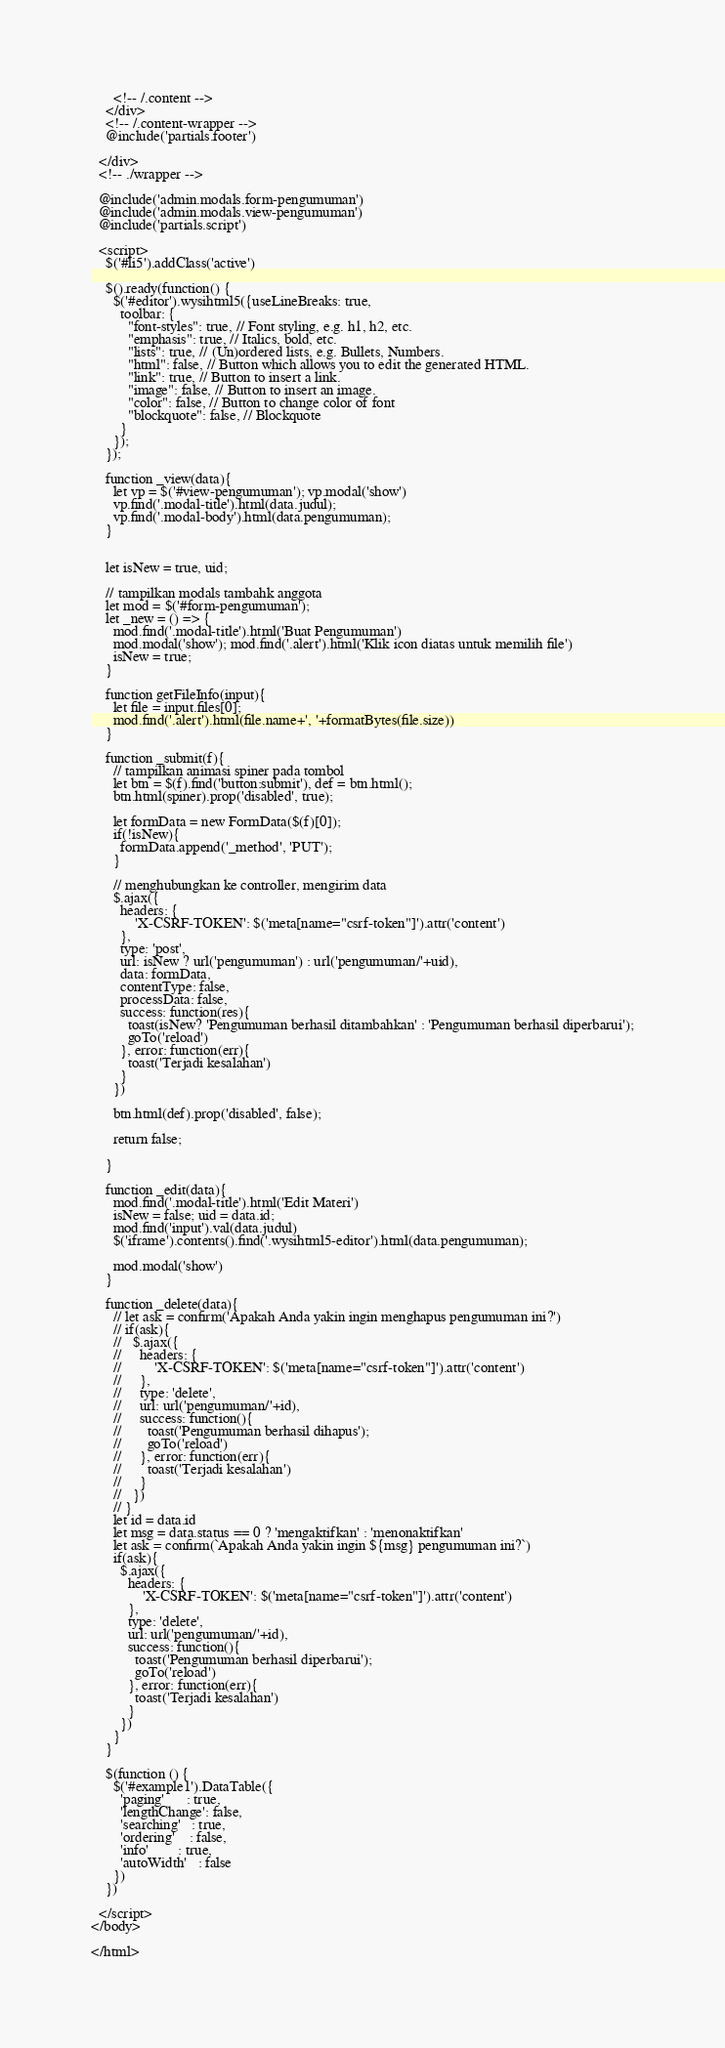<code> <loc_0><loc_0><loc_500><loc_500><_PHP_>      <!-- /.content -->
    </div>
    <!-- /.content-wrapper -->
    @include('partials.footer')

  </div>
  <!-- ./wrapper -->

  @include('admin.modals.form-pengumuman')
  @include('admin.modals.view-pengumuman')
  @include('partials.script')

  <script>
    $('#li5').addClass('active')

    $().ready(function() {
      $('#editor').wysihtml5({useLineBreaks: true,
        toolbar: {
          "font-styles": true, // Font styling, e.g. h1, h2, etc.
          "emphasis": true, // Italics, bold, etc.
          "lists": true, // (Un)ordered lists, e.g. Bullets, Numbers.
          "html": false, // Button which allows you to edit the generated HTML.
          "link": true, // Button to insert a link.
          "image": false, // Button to insert an image.
          "color": false, // Button to change color of font
          "blockquote": false, // Blockquote
        }
      });
    });

    function _view(data){
      let vp = $('#view-pengumuman'); vp.modal('show')
      vp.find('.modal-title').html(data.judul);
      vp.find('.modal-body').html(data.pengumuman);
    }
   

    let isNew = true, uid;

    // tampilkan modals tambahk anggota
    let mod = $('#form-pengumuman');
    let _new = () => {
      mod.find('.modal-title').html('Buat Pengumuman')
      mod.modal('show'); mod.find('.alert').html('Klik icon diatas untuk memilih file')
      isNew = true;
    }

    function getFileInfo(input){
      let file = input.files[0];
      mod.find('.alert').html(file.name+', '+formatBytes(file.size))
    }

    function _submit(f){
      // tampilkan animasi spiner pada tombol
      let btn = $(f).find('button:submit'), def = btn.html();
      btn.html(spiner).prop('disabled', true);

      let formData = new FormData($(f)[0]);
      if(!isNew){
        formData.append('_method', 'PUT');
      }

      // menghubungkan ke controller, mengirim data
      $.ajax({
        headers: {
            'X-CSRF-TOKEN': $('meta[name="csrf-token"]').attr('content')
        },
        type: 'post',
        url: isNew ? url('pengumuman') : url('pengumuman/'+uid),
        data: formData,
        contentType: false,
        processData: false,
        success: function(res){
          toast(isNew? 'Pengumuman berhasil ditambahkan' : 'Pengumuman berhasil diperbarui');
          goTo('reload')
        }, error: function(err){
          toast('Terjadi kesalahan')
        }
      })

      btn.html(def).prop('disabled', false);

      return false;

    }

    function _edit(data){
      mod.find('.modal-title').html('Edit Materi')
      isNew = false; uid = data.id;
      mod.find('input').val(data.judul)
      $('iframe').contents().find('.wysihtml5-editor').html(data.pengumuman);

      mod.modal('show')
    }

    function _delete(data){
      // let ask = confirm('Apakah Anda yakin ingin menghapus pengumuman ini?')
      // if(ask){
      //   $.ajax({
      //     headers: {
      //         'X-CSRF-TOKEN': $('meta[name="csrf-token"]').attr('content')
      //     },
      //     type: 'delete',
      //     url: url('pengumuman/'+id),
      //     success: function(){
      //       toast('Pengumuman berhasil dihapus');
      //       goTo('reload')
      //     }, error: function(err){
      //       toast('Terjadi kesalahan')
      //     }
      //   })
      // }
      let id = data.id
      let msg = data.status == 0 ? 'mengaktifkan' : 'menonaktifkan'
      let ask = confirm(`Apakah Anda yakin ingin ${msg} pengumuman ini?`)
      if(ask){
        $.ajax({
          headers: {
              'X-CSRF-TOKEN': $('meta[name="csrf-token"]').attr('content')
          },
          type: 'delete',
          url: url('pengumuman/'+id),
          success: function(){
            toast('Pengumuman berhasil diperbarui');
            goTo('reload')
          }, error: function(err){
            toast('Terjadi kesalahan')
          }
        })
      }
    }

    $(function () {
      $('#example1').DataTable({
        'paging'      : true,
        'lengthChange': false,
        'searching'   : true,
        'ordering'    : false,
        'info'        : true,
        'autoWidth'   : false
      })
    })

  </script>
</body>

</html></code> 